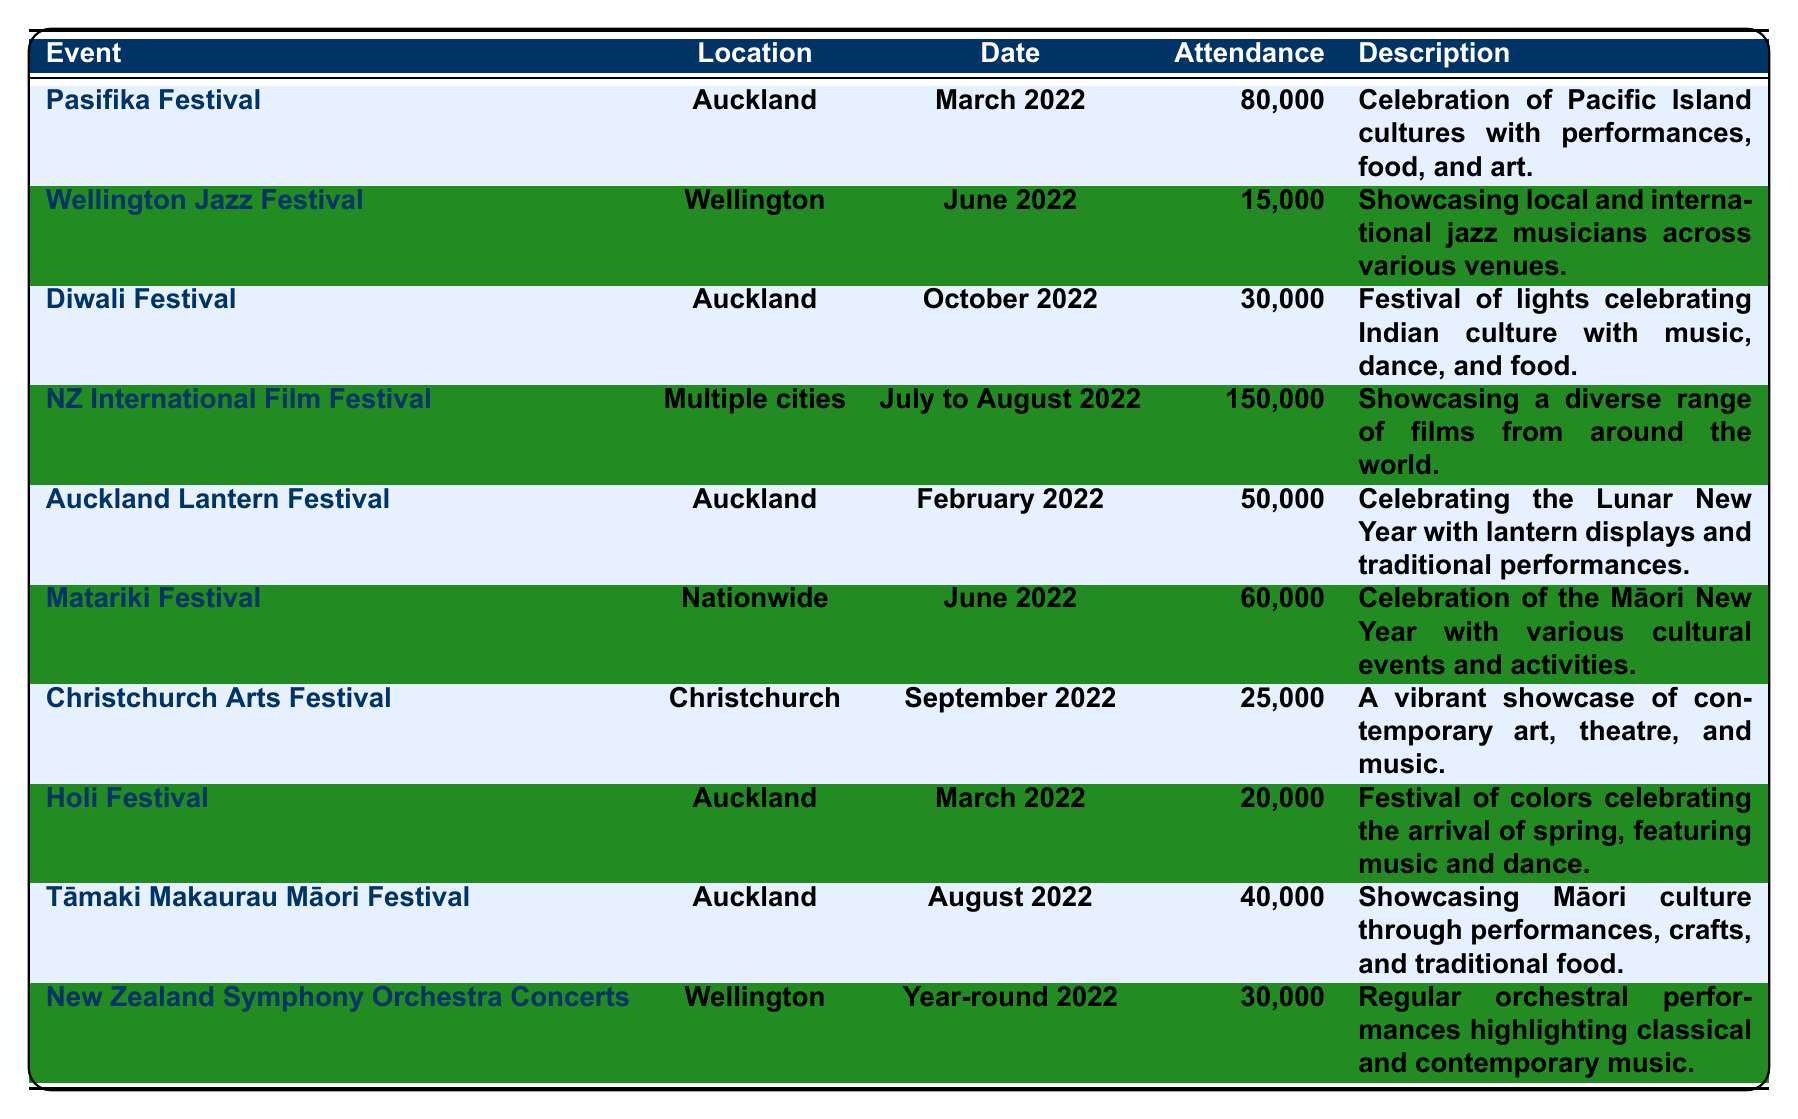What was the attendance at the Pasifika Festival? The table shows that the attendance at the Pasifika Festival, which took place in Auckland in March 2022, was 80,000.
Answer: 80,000 Which event had the lowest attendance? By reviewing the attendance figures in the table, the Wellington Jazz Festival had the lowest attendance of 15,000 in June 2022.
Answer: 15,000 How many attendees were at the Diwali Festival? The Diwali Festival in Auckland in October 2022 had an attendance of 30,000, as indicated in the table.
Answer: 30,000 What is the total attendance for all events held in Auckland? The events in Auckland are Pasifika Festival (80,000), Diwali Festival (30,000), Auckland Lantern Festival (50,000), Holi Festival (20,000), and Tāmaki Makaurau Māori Festival (40,000). The total attendance is 80,000 + 30,000 + 50,000 + 20,000 + 40,000 = 220,000.
Answer: 220,000 How many people attended the NZ International Film Festival? The table states that the total attendance for the NZ International Film Festival, held across multiple cities from July to August 2022, was 150,000.
Answer: 150,000 Is there an event that celebrates Indian culture? Yes, the Diwali Festival is a celebration of Indian culture that includes music, dance, and food, as noted in the description.
Answer: Yes What is the average attendance of all events listed? To find the average, first sum the attendance figures: 80,000 + 15,000 + 30,000 + 150,000 + 50,000 + 60,000 + 25,000 + 20,000 + 40,000 + 30,000 = 480,000. There are 10 events, so the average attendance is 480,000 / 10 = 48,000.
Answer: 48,000 Which two events took place in March? The events listed in March are the Pasifika Festival and the Holi Festival. Both are specified in the date column of the table.
Answer: Pasifika Festival and Holi Festival Did more than 60,000 people attend the Matariki Festival? No, the attendance for the Matariki Festival was 60,000, which means it did not exceed that number.
Answer: No How does the attendance of the Christchurch Arts Festival compare to the Auckland Lantern Festival? The attendance for the Christchurch Arts Festival was 25,000, while the Auckland Lantern Festival had an attendance of 50,000. Therefore, the Auckland Lantern Festival had more attendees.
Answer: Auckland Lantern Festival had more attendees 